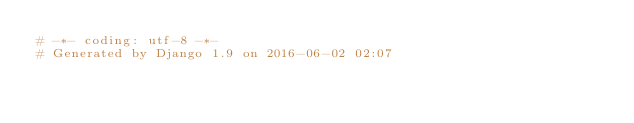Convert code to text. <code><loc_0><loc_0><loc_500><loc_500><_Python_># -*- coding: utf-8 -*-
# Generated by Django 1.9 on 2016-06-02 02:07</code> 